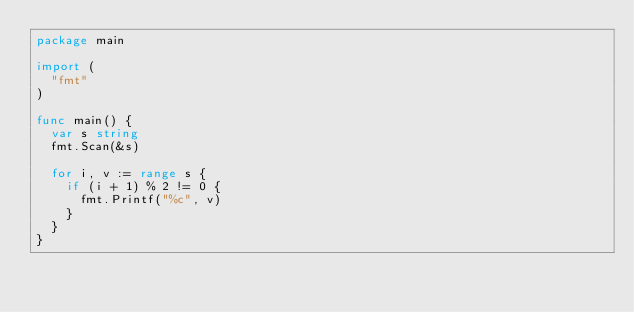<code> <loc_0><loc_0><loc_500><loc_500><_Go_>package main

import (
  "fmt"
)

func main() {
  var s string
  fmt.Scan(&s)

  for i, v := range s {
    if (i + 1) % 2 != 0 {
      fmt.Printf("%c", v)
    }
  }
}</code> 